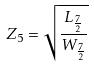<formula> <loc_0><loc_0><loc_500><loc_500>Z _ { 5 } = \sqrt { \frac { L _ { \frac { 7 } { 2 } } } { W _ { \frac { 7 } { 2 } } } }</formula> 